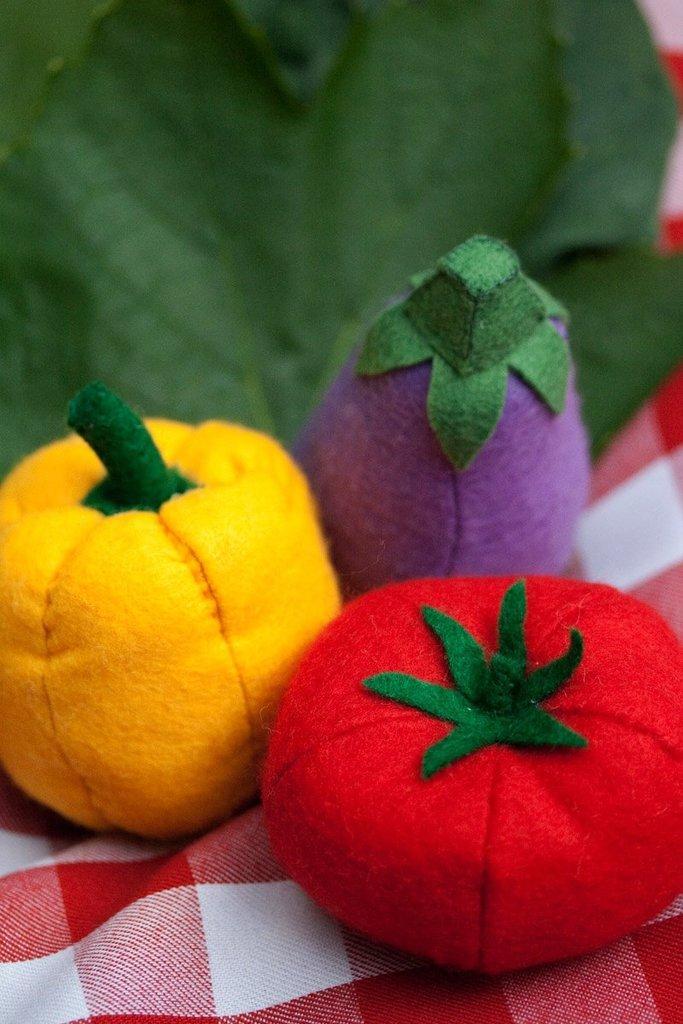Can you describe this image briefly? In foreground we can a cloth which is red and white color. In the middle we three vegetables are capsicum, brinjal and tomato. on the top most we have green color leaf which is in blurred. 